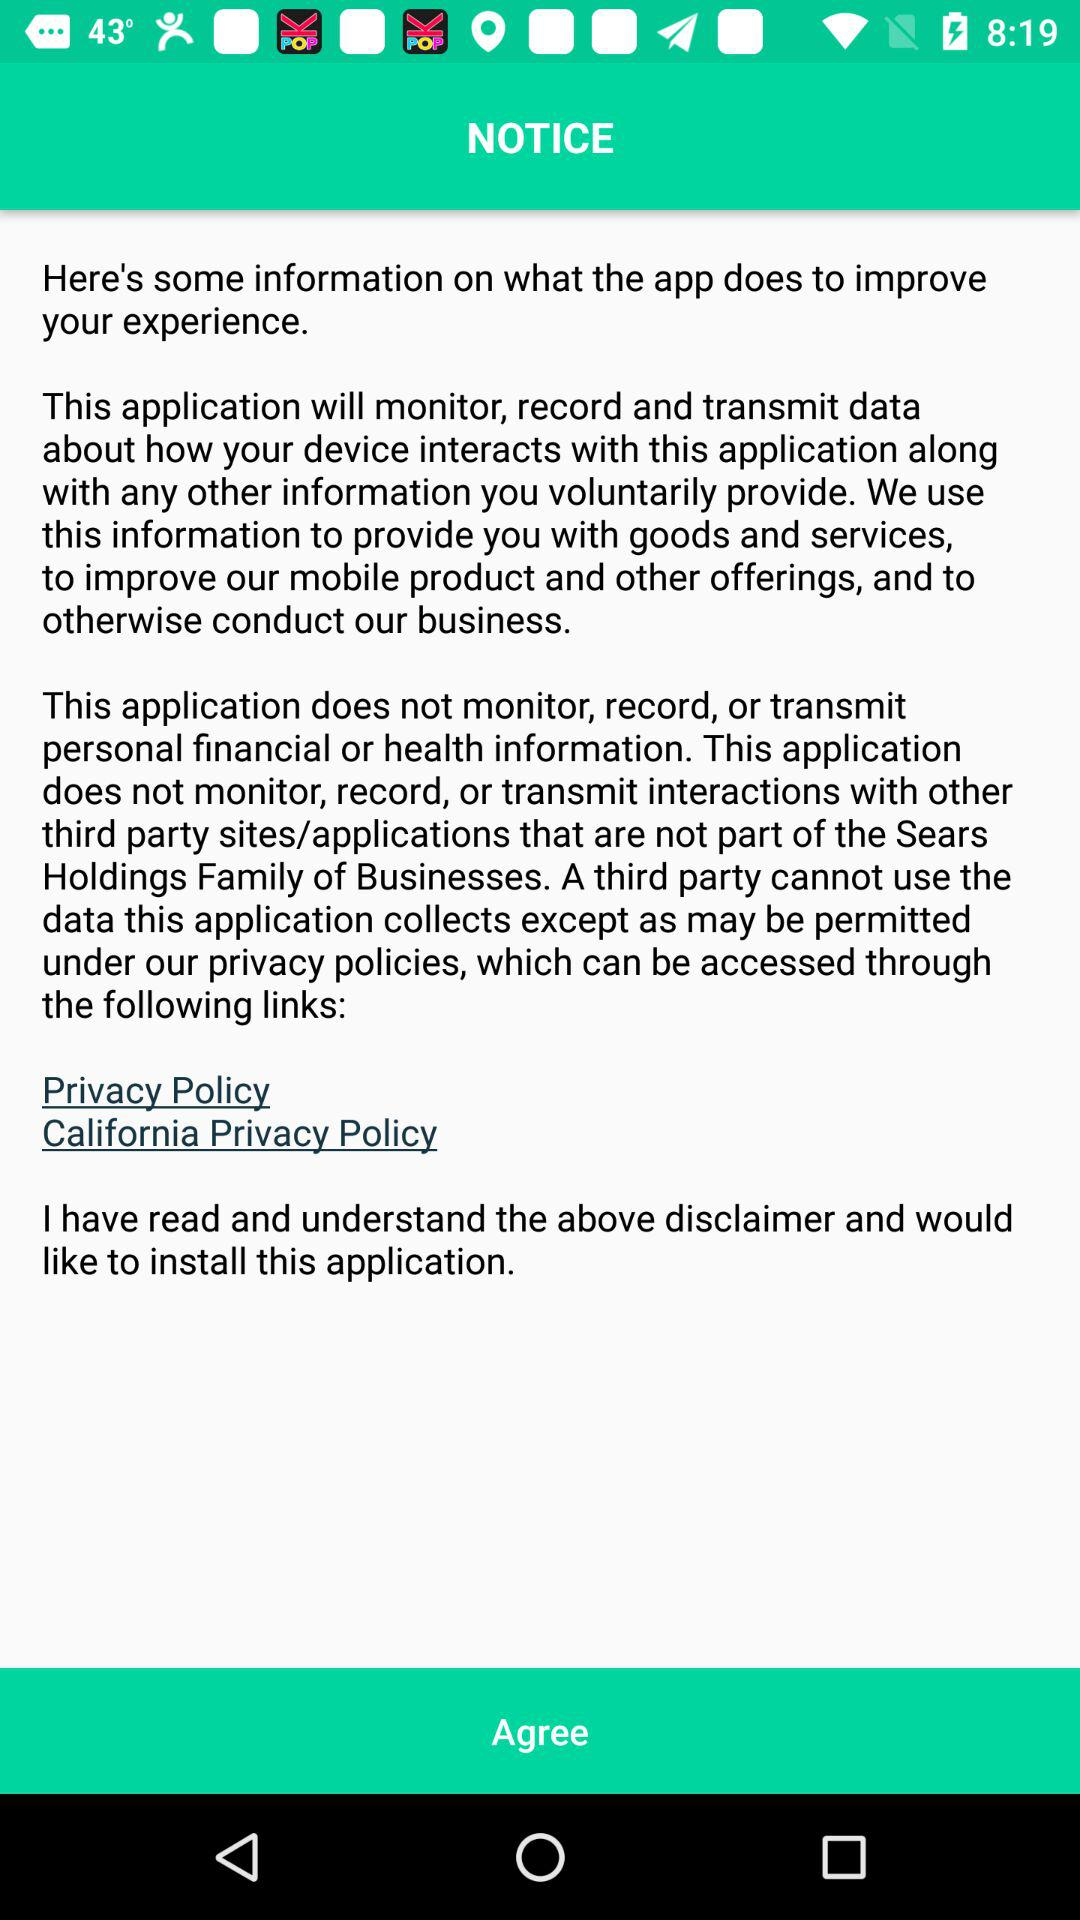How many links are there to the privacy policy?
Answer the question using a single word or phrase. 2 